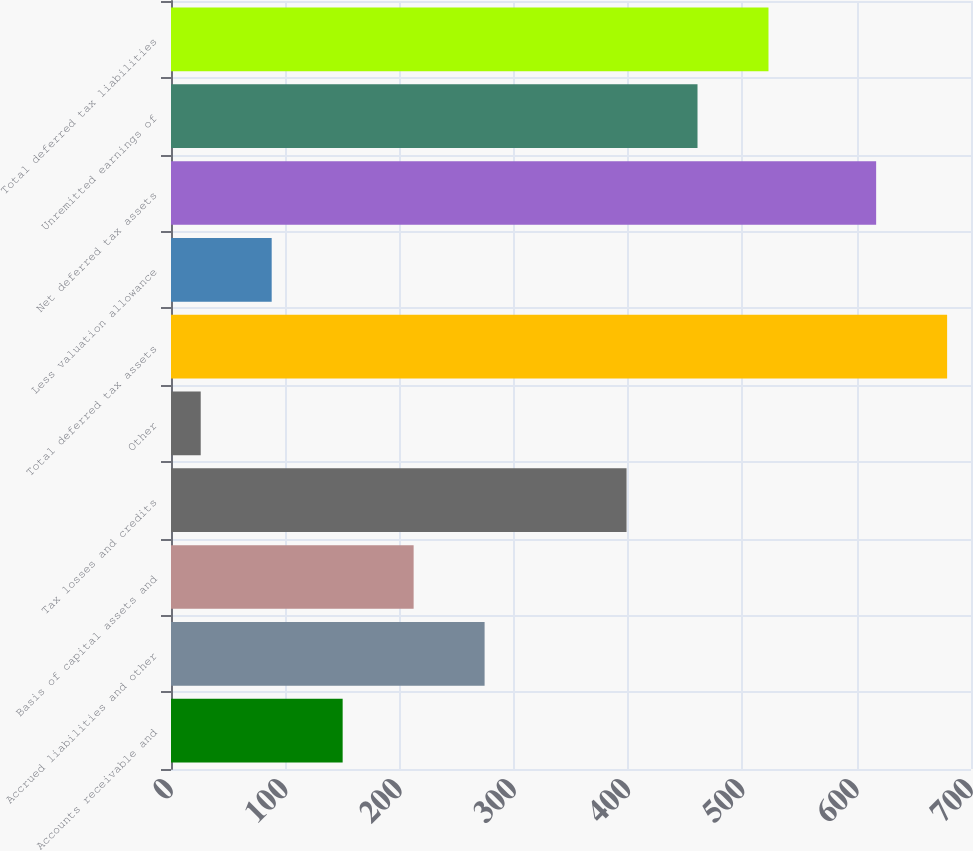Convert chart. <chart><loc_0><loc_0><loc_500><loc_500><bar_chart><fcel>Accounts receivable and<fcel>Accrued liabilities and other<fcel>Basis of capital assets and<fcel>Tax losses and credits<fcel>Other<fcel>Total deferred tax assets<fcel>Less valuation allowance<fcel>Net deferred tax assets<fcel>Unremitted earnings of<fcel>Total deferred tax liabilities<nl><fcel>150.2<fcel>274.4<fcel>212.3<fcel>398.6<fcel>26<fcel>679.1<fcel>88.1<fcel>617<fcel>460.7<fcel>522.8<nl></chart> 